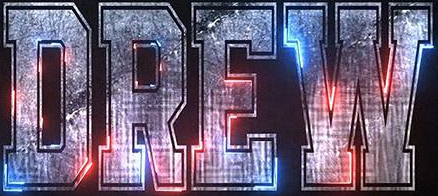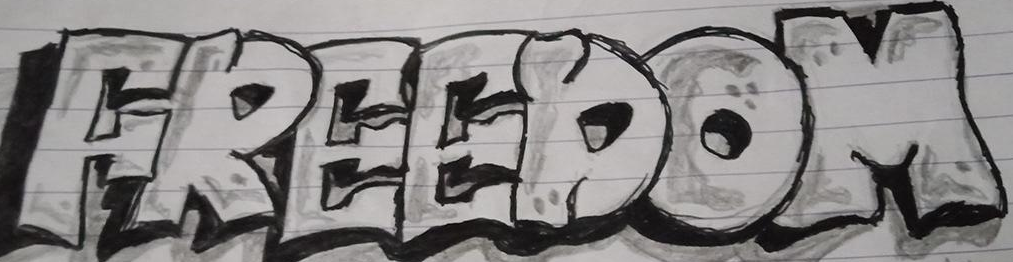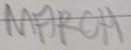Identify the words shown in these images in order, separated by a semicolon. DREW; FREEDOM; MARCH 